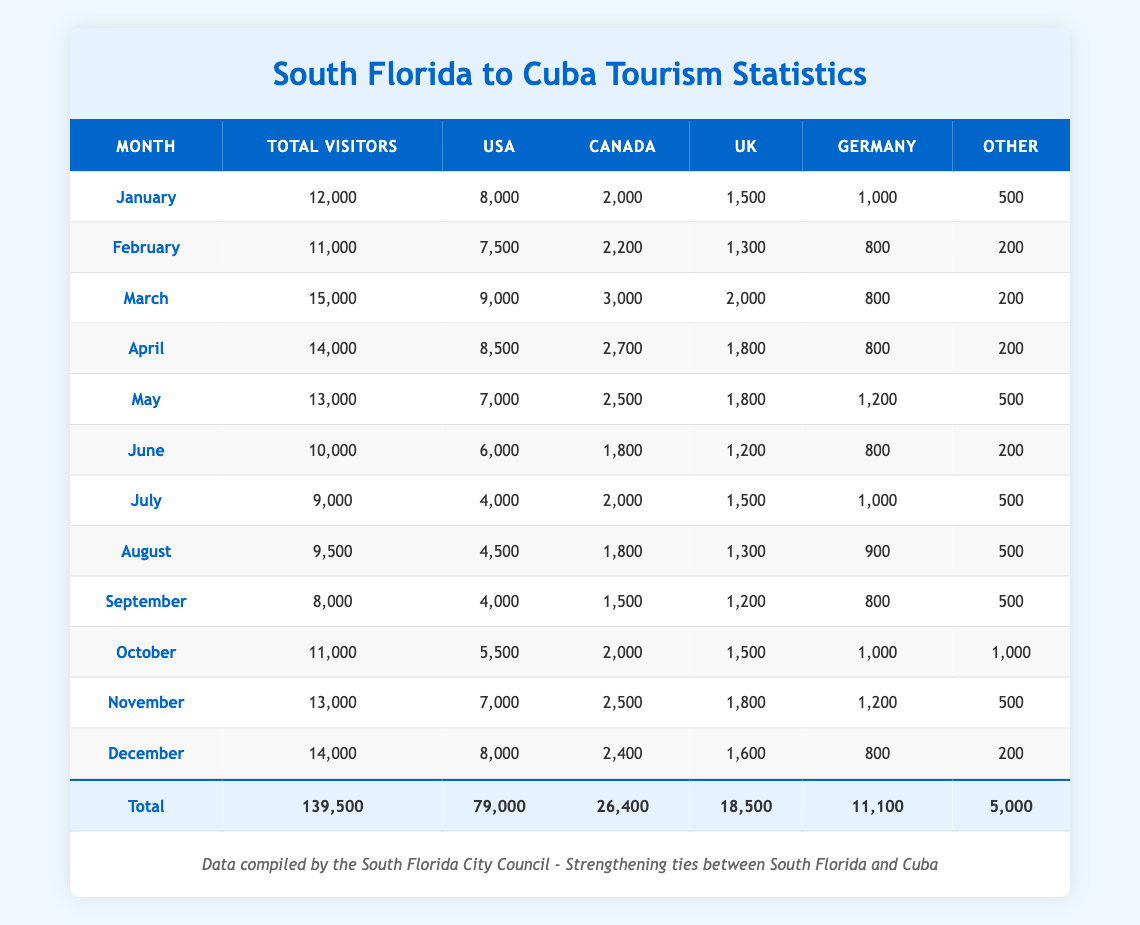What was the total number of visitors from the USA in December? In December, the table shows that the total number of visitors from the USA is listed as 8,000.
Answer: 8,000 Which month had the highest number of total visitors? By evaluating the 'Total Visitors' column, March has the highest value at 15,000 visitors.
Answer: March How many visitors from Canada visited Cuba in the first half of the year? Adding up the visitors from Canada for January (2,000), February (2,200), March (3,000), April (2,700), May (2,500), and June (1,800) gives a total of 2,000 + 2,200 + 3,000 + 2,700 + 2,500 + 1,800 = 14,200 visitors.
Answer: 14,200 Did the number of visitors from the UK increase from July to August? The table shows that in July, there were 1,500 visitors from the UK and in August, there were 1,300 visitors. This indicates a decrease in visitors from the UK.
Answer: No What is the average number of total visitors per month over the year? To calculate the average, sum the total visitors for each month (139,500) and divide by the number of months (12). Thus, 139,500 / 12 = 11,625.
Answer: 11,625 How many more visitors were there from Germany than from the 'Other' category in November? In November, there were 1,200 visitors from Germany and 500 from 'Other'. The difference is calculated as 1,200 - 500 = 700.
Answer: 700 Which month has the lowest number of total visitors, and what is that number? September has the lowest number of total visitors, recorded at 8,000 visitors.
Answer: 8,000 If we look at the total visitors from the UK over the year, what percentage of the total visitors does this represent? The total number of visitors from the UK is 18,500. To find the percentage, divide 18,500 by the total number of visitors (139,500) and multiply by 100: (18,500 / 139,500) * 100 = approximately 13.27%.
Answer: Approximately 13.27% 